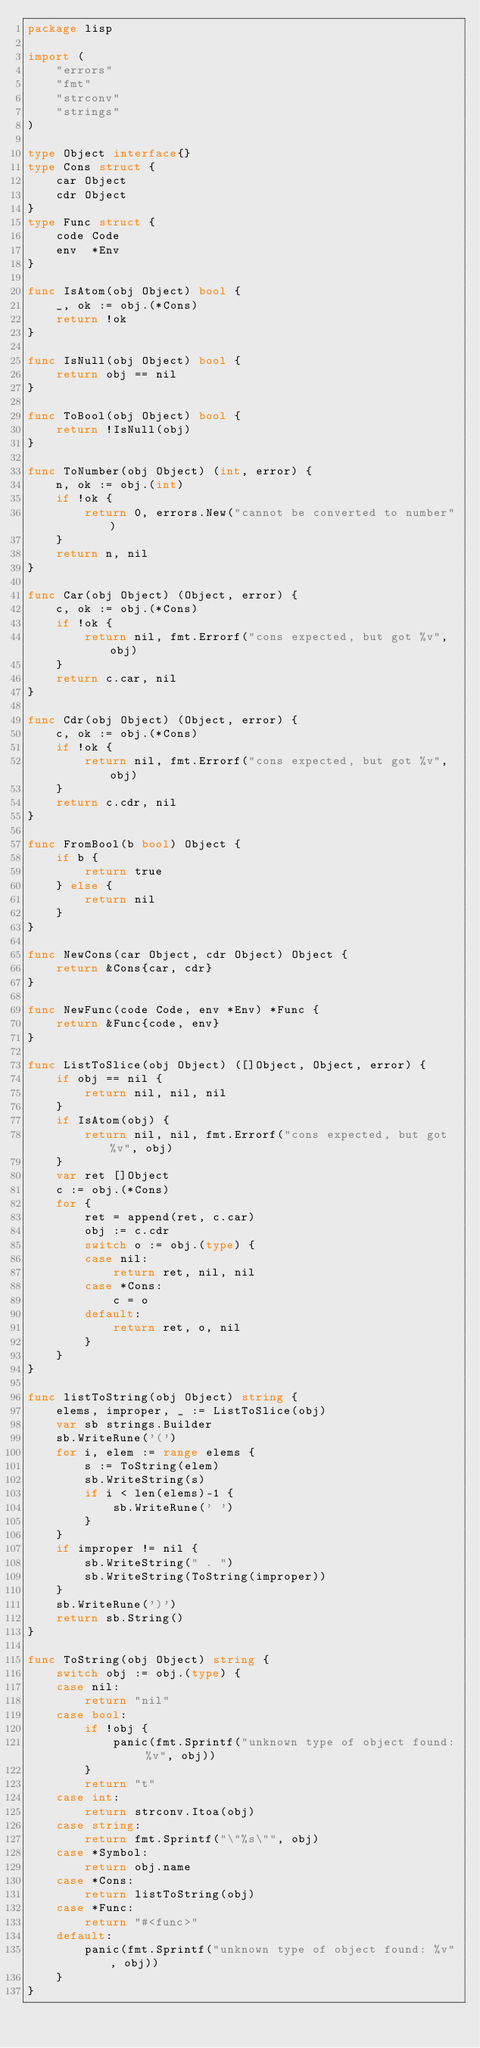Convert code to text. <code><loc_0><loc_0><loc_500><loc_500><_Go_>package lisp

import (
	"errors"
	"fmt"
	"strconv"
	"strings"
)

type Object interface{}
type Cons struct {
	car Object
	cdr Object
}
type Func struct {
	code Code
	env  *Env
}

func IsAtom(obj Object) bool {
	_, ok := obj.(*Cons)
	return !ok
}

func IsNull(obj Object) bool {
	return obj == nil
}

func ToBool(obj Object) bool {
	return !IsNull(obj)
}

func ToNumber(obj Object) (int, error) {
	n, ok := obj.(int)
	if !ok {
		return 0, errors.New("cannot be converted to number")
	}
	return n, nil
}

func Car(obj Object) (Object, error) {
	c, ok := obj.(*Cons)
	if !ok {
		return nil, fmt.Errorf("cons expected, but got %v", obj)
	}
	return c.car, nil
}

func Cdr(obj Object) (Object, error) {
	c, ok := obj.(*Cons)
	if !ok {
		return nil, fmt.Errorf("cons expected, but got %v", obj)
	}
	return c.cdr, nil
}

func FromBool(b bool) Object {
	if b {
		return true
	} else {
		return nil
	}
}

func NewCons(car Object, cdr Object) Object {
	return &Cons{car, cdr}
}

func NewFunc(code Code, env *Env) *Func {
	return &Func{code, env}
}

func ListToSlice(obj Object) ([]Object, Object, error) {
	if obj == nil {
		return nil, nil, nil
	}
	if IsAtom(obj) {
		return nil, nil, fmt.Errorf("cons expected, but got %v", obj)
	}
	var ret []Object
	c := obj.(*Cons)
	for {
		ret = append(ret, c.car)
		obj := c.cdr
		switch o := obj.(type) {
		case nil:
			return ret, nil, nil
		case *Cons:
			c = o
		default:
			return ret, o, nil
		}
	}
}

func listToString(obj Object) string {
	elems, improper, _ := ListToSlice(obj)
	var sb strings.Builder
	sb.WriteRune('(')
	for i, elem := range elems {
		s := ToString(elem)
		sb.WriteString(s)
		if i < len(elems)-1 {
			sb.WriteRune(' ')
		}
	}
	if improper != nil {
		sb.WriteString(" . ")
		sb.WriteString(ToString(improper))
	}
	sb.WriteRune(')')
	return sb.String()
}

func ToString(obj Object) string {
	switch obj := obj.(type) {
	case nil:
		return "nil"
	case bool:
		if !obj {
			panic(fmt.Sprintf("unknown type of object found: %v", obj))
		}
		return "t"
	case int:
		return strconv.Itoa(obj)
	case string:
		return fmt.Sprintf("\"%s\"", obj)
	case *Symbol:
		return obj.name
	case *Cons:
		return listToString(obj)
	case *Func:
		return "#<func>"
	default:
		panic(fmt.Sprintf("unknown type of object found: %v", obj))
	}
}
</code> 